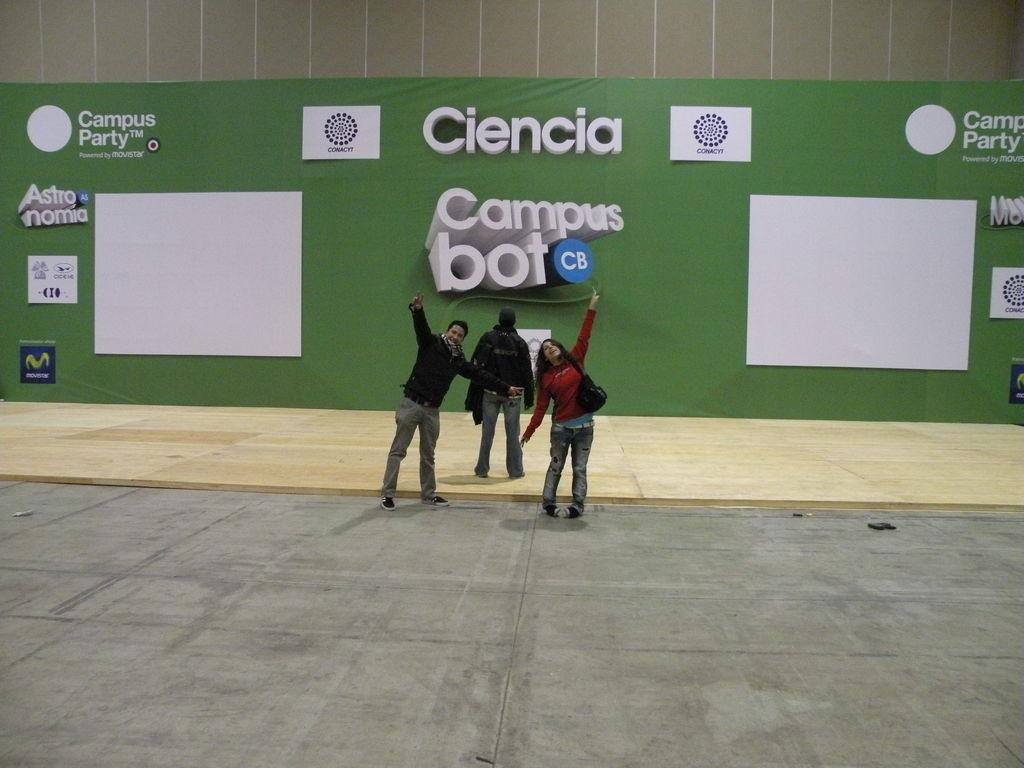How many people are in the image? There are three persons standing in the center of the image. What are the persons holding in the image? The persons are holding objects. What can be seen in the background of the image? There is a wall and banners in the background of the image. Can you see any gloves on the persons' hands in the image? There is no mention of gloves in the image, so we cannot determine if any are present. Are there any ants visible on the persons or objects in the image? There is no mention of ants in the image, so we cannot determine if any are present. 